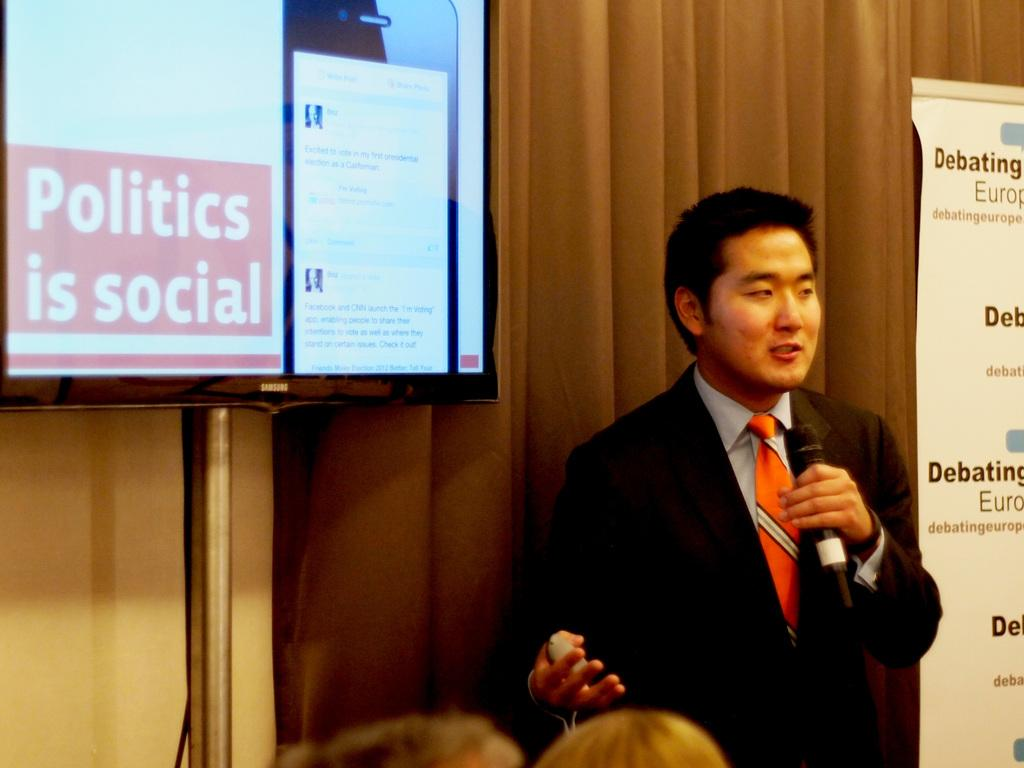What is the man in the image doing? The man is standing in the image and holding a mic in his hand. What can be seen in the background of the image? There is a display screen and advertisements in the background of the image. Is there any additional feature associated with the background? Yes, there is a curtain associated with the background of the image. How many chickens are visible in the image? There are no chickens present in the image. What type of baseball game is being played in the background of the image? There is no baseball game present in the image; it features a man holding a mic, a display screen, advertisements, and a curtain. 